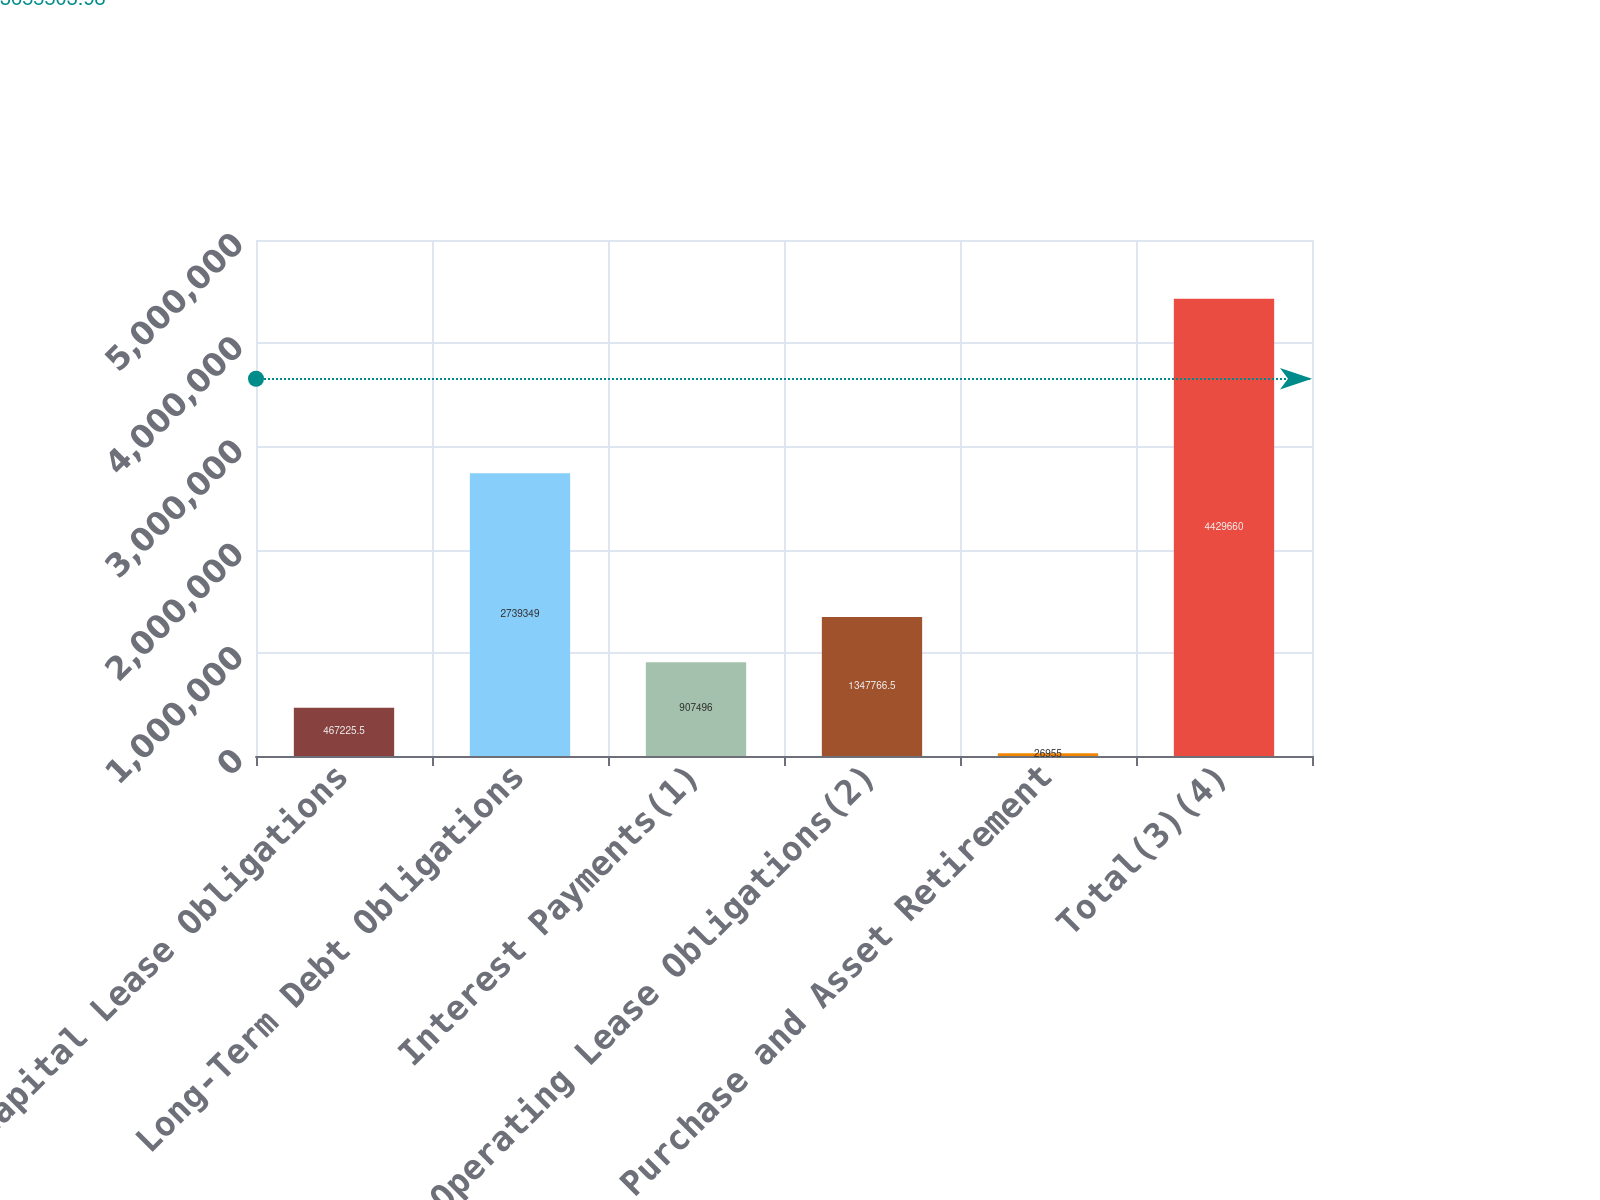Convert chart to OTSL. <chart><loc_0><loc_0><loc_500><loc_500><bar_chart><fcel>Capital Lease Obligations<fcel>Long-Term Debt Obligations<fcel>Interest Payments(1)<fcel>Operating Lease Obligations(2)<fcel>Purchase and Asset Retirement<fcel>Total(3)(4)<nl><fcel>467226<fcel>2.73935e+06<fcel>907496<fcel>1.34777e+06<fcel>26955<fcel>4.42966e+06<nl></chart> 